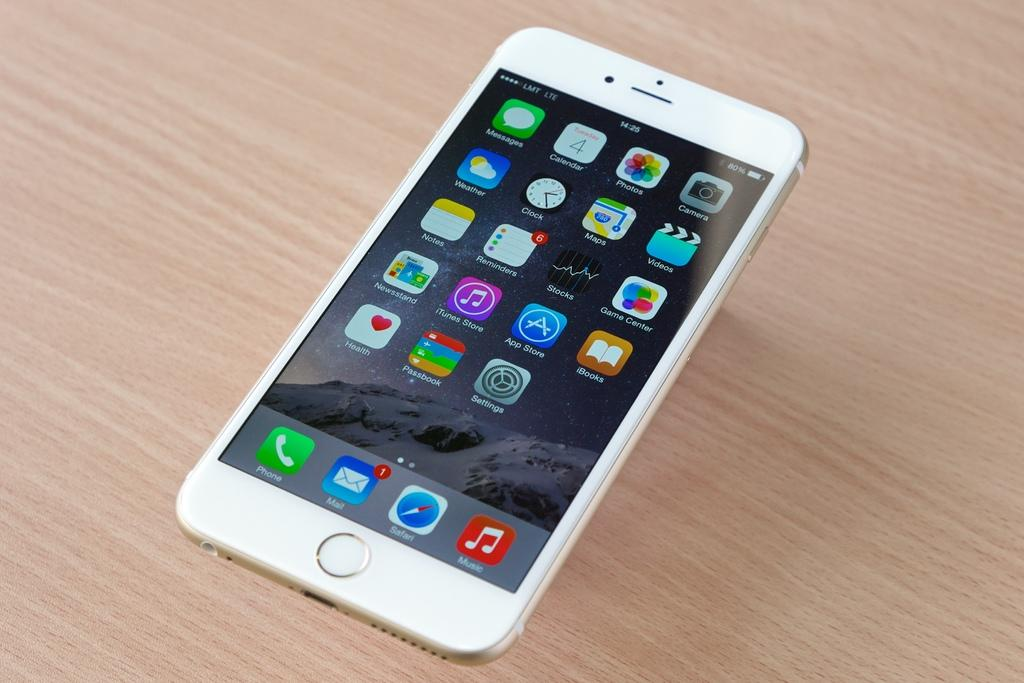<image>
Create a compact narrative representing the image presented. The red app in the bottom right corner is for Music 